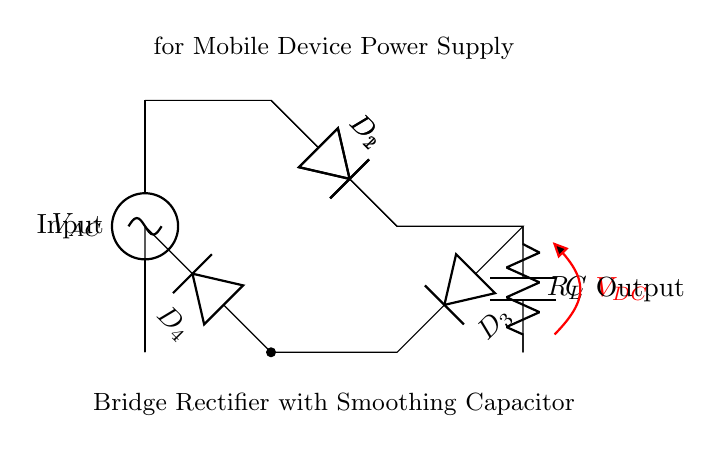What type of rectifier is shown in the diagram? The circuit diagram depicts a bridge rectifier, characterized by its four diodes arranged in a bridge configuration. This arrangement allows for rectification of both halves of the AC input waveform.
Answer: Bridge rectifier How many diodes are used in this circuit? The circuit includes four diodes labeled as D1, D2, D3, and D4, which are integral to forming the bridge rectifier. Each diode plays a role in allowing current to flow during different halves of the AC cycle.
Answer: Four diodes What is the function of the capacitor in this circuit? The smoothing capacitor, labeled C, serves to reduce the ripple in the output voltage by storing charge and releasing it when the output voltage dips, thus providing a more stable DC output.
Answer: Smoothing What is the output voltage type from the bridge rectifier? The output voltage from the bridge rectifier will be a direct current (DC) voltage, achieved by converting the alternating current (AC) into a usable form for mobile device power supply.
Answer: DC When is the current through the load resistor at its highest? Current through the load resistor R_L reaches its peak value when the output voltage is maximized, which occurs immediately after the capacitor has charged but before it starts discharging significantly. The timing is based on the capacitor's charge-discharge cycle relative to the AC input frequency.
Answer: After charging What is the purpose of the load resistor in this circuit? The load resistor, labeled R_L, represents the component consuming the power supplied by the rectifier. It provides the necessary load for the circuit’s output, which is essential for device operation.
Answer: Power consumption What is the role of the AC source in the circuit? The AC source, labeled V_AC, is responsible for providing alternating current which is then converted into direct current by the bridge rectifier, illustrating the fundamental role of the source in initiating the power conversion process.
Answer: Input voltage 